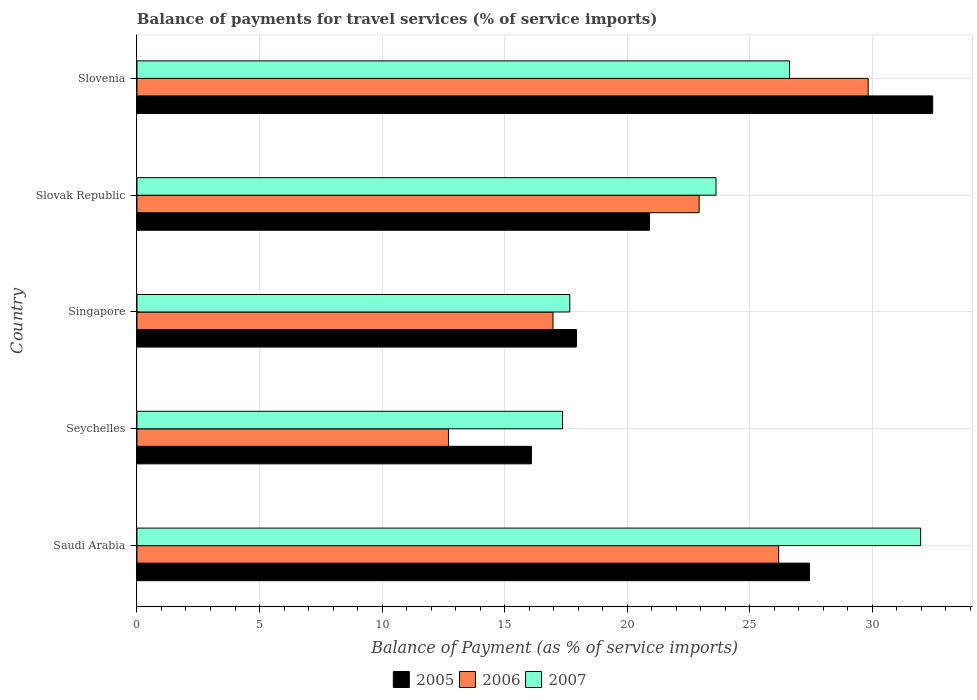How many groups of bars are there?
Your response must be concise. 5. How many bars are there on the 1st tick from the top?
Your answer should be very brief. 3. What is the label of the 1st group of bars from the top?
Offer a very short reply. Slovenia. What is the balance of payments for travel services in 2007 in Slovak Republic?
Ensure brevity in your answer.  23.62. Across all countries, what is the maximum balance of payments for travel services in 2007?
Provide a succinct answer. 31.97. Across all countries, what is the minimum balance of payments for travel services in 2007?
Ensure brevity in your answer.  17.36. In which country was the balance of payments for travel services in 2007 maximum?
Make the answer very short. Saudi Arabia. In which country was the balance of payments for travel services in 2006 minimum?
Your answer should be compact. Seychelles. What is the total balance of payments for travel services in 2006 in the graph?
Give a very brief answer. 108.62. What is the difference between the balance of payments for travel services in 2007 in Seychelles and that in Slovenia?
Give a very brief answer. -9.26. What is the difference between the balance of payments for travel services in 2007 in Slovak Republic and the balance of payments for travel services in 2006 in Singapore?
Your answer should be compact. 6.65. What is the average balance of payments for travel services in 2005 per country?
Provide a succinct answer. 22.97. What is the difference between the balance of payments for travel services in 2007 and balance of payments for travel services in 2006 in Seychelles?
Offer a very short reply. 4.65. In how many countries, is the balance of payments for travel services in 2006 greater than 17 %?
Your answer should be very brief. 3. What is the ratio of the balance of payments for travel services in 2006 in Seychelles to that in Singapore?
Your answer should be very brief. 0.75. What is the difference between the highest and the second highest balance of payments for travel services in 2007?
Give a very brief answer. 5.35. What is the difference between the highest and the lowest balance of payments for travel services in 2006?
Provide a short and direct response. 17.12. Is the sum of the balance of payments for travel services in 2005 in Saudi Arabia and Seychelles greater than the maximum balance of payments for travel services in 2006 across all countries?
Make the answer very short. Yes. What does the 1st bar from the bottom in Slovenia represents?
Provide a short and direct response. 2005. How many bars are there?
Keep it short and to the point. 15. Are all the bars in the graph horizontal?
Provide a succinct answer. Yes. What is the difference between two consecutive major ticks on the X-axis?
Provide a short and direct response. 5. Does the graph contain any zero values?
Provide a succinct answer. No. Does the graph contain grids?
Give a very brief answer. Yes. Where does the legend appear in the graph?
Your answer should be compact. Bottom center. How are the legend labels stacked?
Offer a terse response. Horizontal. What is the title of the graph?
Provide a short and direct response. Balance of payments for travel services (% of service imports). Does "1970" appear as one of the legend labels in the graph?
Keep it short and to the point. No. What is the label or title of the X-axis?
Your answer should be compact. Balance of Payment (as % of service imports). What is the Balance of Payment (as % of service imports) of 2005 in Saudi Arabia?
Your answer should be compact. 27.44. What is the Balance of Payment (as % of service imports) in 2006 in Saudi Arabia?
Ensure brevity in your answer.  26.18. What is the Balance of Payment (as % of service imports) of 2007 in Saudi Arabia?
Offer a very short reply. 31.97. What is the Balance of Payment (as % of service imports) in 2005 in Seychelles?
Ensure brevity in your answer.  16.09. What is the Balance of Payment (as % of service imports) in 2006 in Seychelles?
Offer a terse response. 12.71. What is the Balance of Payment (as % of service imports) of 2007 in Seychelles?
Ensure brevity in your answer.  17.36. What is the Balance of Payment (as % of service imports) in 2005 in Singapore?
Your response must be concise. 17.93. What is the Balance of Payment (as % of service imports) in 2006 in Singapore?
Your response must be concise. 16.97. What is the Balance of Payment (as % of service imports) in 2007 in Singapore?
Your answer should be compact. 17.66. What is the Balance of Payment (as % of service imports) in 2005 in Slovak Republic?
Offer a terse response. 20.91. What is the Balance of Payment (as % of service imports) of 2006 in Slovak Republic?
Your response must be concise. 22.93. What is the Balance of Payment (as % of service imports) of 2007 in Slovak Republic?
Give a very brief answer. 23.62. What is the Balance of Payment (as % of service imports) in 2005 in Slovenia?
Ensure brevity in your answer.  32.46. What is the Balance of Payment (as % of service imports) in 2006 in Slovenia?
Your response must be concise. 29.83. What is the Balance of Payment (as % of service imports) in 2007 in Slovenia?
Give a very brief answer. 26.62. Across all countries, what is the maximum Balance of Payment (as % of service imports) in 2005?
Give a very brief answer. 32.46. Across all countries, what is the maximum Balance of Payment (as % of service imports) of 2006?
Offer a terse response. 29.83. Across all countries, what is the maximum Balance of Payment (as % of service imports) in 2007?
Your response must be concise. 31.97. Across all countries, what is the minimum Balance of Payment (as % of service imports) of 2005?
Keep it short and to the point. 16.09. Across all countries, what is the minimum Balance of Payment (as % of service imports) of 2006?
Offer a terse response. 12.71. Across all countries, what is the minimum Balance of Payment (as % of service imports) in 2007?
Your answer should be very brief. 17.36. What is the total Balance of Payment (as % of service imports) in 2005 in the graph?
Offer a terse response. 114.83. What is the total Balance of Payment (as % of service imports) of 2006 in the graph?
Give a very brief answer. 108.62. What is the total Balance of Payment (as % of service imports) of 2007 in the graph?
Your response must be concise. 117.23. What is the difference between the Balance of Payment (as % of service imports) in 2005 in Saudi Arabia and that in Seychelles?
Provide a short and direct response. 11.34. What is the difference between the Balance of Payment (as % of service imports) of 2006 in Saudi Arabia and that in Seychelles?
Your answer should be compact. 13.47. What is the difference between the Balance of Payment (as % of service imports) in 2007 in Saudi Arabia and that in Seychelles?
Ensure brevity in your answer.  14.61. What is the difference between the Balance of Payment (as % of service imports) of 2005 in Saudi Arabia and that in Singapore?
Provide a succinct answer. 9.51. What is the difference between the Balance of Payment (as % of service imports) in 2006 in Saudi Arabia and that in Singapore?
Your response must be concise. 9.2. What is the difference between the Balance of Payment (as % of service imports) in 2007 in Saudi Arabia and that in Singapore?
Offer a very short reply. 14.31. What is the difference between the Balance of Payment (as % of service imports) of 2005 in Saudi Arabia and that in Slovak Republic?
Offer a terse response. 6.53. What is the difference between the Balance of Payment (as % of service imports) in 2006 in Saudi Arabia and that in Slovak Republic?
Your answer should be compact. 3.24. What is the difference between the Balance of Payment (as % of service imports) in 2007 in Saudi Arabia and that in Slovak Republic?
Ensure brevity in your answer.  8.35. What is the difference between the Balance of Payment (as % of service imports) in 2005 in Saudi Arabia and that in Slovenia?
Offer a very short reply. -5.03. What is the difference between the Balance of Payment (as % of service imports) in 2006 in Saudi Arabia and that in Slovenia?
Offer a very short reply. -3.65. What is the difference between the Balance of Payment (as % of service imports) of 2007 in Saudi Arabia and that in Slovenia?
Give a very brief answer. 5.35. What is the difference between the Balance of Payment (as % of service imports) in 2005 in Seychelles and that in Singapore?
Ensure brevity in your answer.  -1.84. What is the difference between the Balance of Payment (as % of service imports) in 2006 in Seychelles and that in Singapore?
Provide a short and direct response. -4.26. What is the difference between the Balance of Payment (as % of service imports) of 2007 in Seychelles and that in Singapore?
Your answer should be compact. -0.29. What is the difference between the Balance of Payment (as % of service imports) in 2005 in Seychelles and that in Slovak Republic?
Ensure brevity in your answer.  -4.82. What is the difference between the Balance of Payment (as % of service imports) in 2006 in Seychelles and that in Slovak Republic?
Ensure brevity in your answer.  -10.23. What is the difference between the Balance of Payment (as % of service imports) in 2007 in Seychelles and that in Slovak Republic?
Keep it short and to the point. -6.26. What is the difference between the Balance of Payment (as % of service imports) in 2005 in Seychelles and that in Slovenia?
Keep it short and to the point. -16.37. What is the difference between the Balance of Payment (as % of service imports) of 2006 in Seychelles and that in Slovenia?
Give a very brief answer. -17.12. What is the difference between the Balance of Payment (as % of service imports) in 2007 in Seychelles and that in Slovenia?
Provide a short and direct response. -9.26. What is the difference between the Balance of Payment (as % of service imports) in 2005 in Singapore and that in Slovak Republic?
Make the answer very short. -2.98. What is the difference between the Balance of Payment (as % of service imports) of 2006 in Singapore and that in Slovak Republic?
Your answer should be very brief. -5.96. What is the difference between the Balance of Payment (as % of service imports) of 2007 in Singapore and that in Slovak Republic?
Ensure brevity in your answer.  -5.97. What is the difference between the Balance of Payment (as % of service imports) of 2005 in Singapore and that in Slovenia?
Keep it short and to the point. -14.53. What is the difference between the Balance of Payment (as % of service imports) of 2006 in Singapore and that in Slovenia?
Your response must be concise. -12.86. What is the difference between the Balance of Payment (as % of service imports) of 2007 in Singapore and that in Slovenia?
Your answer should be very brief. -8.96. What is the difference between the Balance of Payment (as % of service imports) of 2005 in Slovak Republic and that in Slovenia?
Provide a short and direct response. -11.55. What is the difference between the Balance of Payment (as % of service imports) of 2006 in Slovak Republic and that in Slovenia?
Keep it short and to the point. -6.9. What is the difference between the Balance of Payment (as % of service imports) of 2007 in Slovak Republic and that in Slovenia?
Your response must be concise. -3. What is the difference between the Balance of Payment (as % of service imports) of 2005 in Saudi Arabia and the Balance of Payment (as % of service imports) of 2006 in Seychelles?
Your answer should be compact. 14.73. What is the difference between the Balance of Payment (as % of service imports) in 2005 in Saudi Arabia and the Balance of Payment (as % of service imports) in 2007 in Seychelles?
Give a very brief answer. 10.07. What is the difference between the Balance of Payment (as % of service imports) in 2006 in Saudi Arabia and the Balance of Payment (as % of service imports) in 2007 in Seychelles?
Give a very brief answer. 8.82. What is the difference between the Balance of Payment (as % of service imports) of 2005 in Saudi Arabia and the Balance of Payment (as % of service imports) of 2006 in Singapore?
Offer a terse response. 10.46. What is the difference between the Balance of Payment (as % of service imports) in 2005 in Saudi Arabia and the Balance of Payment (as % of service imports) in 2007 in Singapore?
Keep it short and to the point. 9.78. What is the difference between the Balance of Payment (as % of service imports) of 2006 in Saudi Arabia and the Balance of Payment (as % of service imports) of 2007 in Singapore?
Your response must be concise. 8.52. What is the difference between the Balance of Payment (as % of service imports) in 2005 in Saudi Arabia and the Balance of Payment (as % of service imports) in 2006 in Slovak Republic?
Your response must be concise. 4.5. What is the difference between the Balance of Payment (as % of service imports) in 2005 in Saudi Arabia and the Balance of Payment (as % of service imports) in 2007 in Slovak Republic?
Your answer should be very brief. 3.81. What is the difference between the Balance of Payment (as % of service imports) in 2006 in Saudi Arabia and the Balance of Payment (as % of service imports) in 2007 in Slovak Republic?
Provide a short and direct response. 2.56. What is the difference between the Balance of Payment (as % of service imports) of 2005 in Saudi Arabia and the Balance of Payment (as % of service imports) of 2006 in Slovenia?
Provide a succinct answer. -2.39. What is the difference between the Balance of Payment (as % of service imports) in 2005 in Saudi Arabia and the Balance of Payment (as % of service imports) in 2007 in Slovenia?
Provide a short and direct response. 0.82. What is the difference between the Balance of Payment (as % of service imports) in 2006 in Saudi Arabia and the Balance of Payment (as % of service imports) in 2007 in Slovenia?
Provide a short and direct response. -0.44. What is the difference between the Balance of Payment (as % of service imports) of 2005 in Seychelles and the Balance of Payment (as % of service imports) of 2006 in Singapore?
Give a very brief answer. -0.88. What is the difference between the Balance of Payment (as % of service imports) in 2005 in Seychelles and the Balance of Payment (as % of service imports) in 2007 in Singapore?
Provide a short and direct response. -1.56. What is the difference between the Balance of Payment (as % of service imports) in 2006 in Seychelles and the Balance of Payment (as % of service imports) in 2007 in Singapore?
Provide a short and direct response. -4.95. What is the difference between the Balance of Payment (as % of service imports) of 2005 in Seychelles and the Balance of Payment (as % of service imports) of 2006 in Slovak Republic?
Your answer should be compact. -6.84. What is the difference between the Balance of Payment (as % of service imports) of 2005 in Seychelles and the Balance of Payment (as % of service imports) of 2007 in Slovak Republic?
Offer a very short reply. -7.53. What is the difference between the Balance of Payment (as % of service imports) in 2006 in Seychelles and the Balance of Payment (as % of service imports) in 2007 in Slovak Republic?
Make the answer very short. -10.91. What is the difference between the Balance of Payment (as % of service imports) of 2005 in Seychelles and the Balance of Payment (as % of service imports) of 2006 in Slovenia?
Your answer should be compact. -13.74. What is the difference between the Balance of Payment (as % of service imports) of 2005 in Seychelles and the Balance of Payment (as % of service imports) of 2007 in Slovenia?
Your answer should be compact. -10.53. What is the difference between the Balance of Payment (as % of service imports) of 2006 in Seychelles and the Balance of Payment (as % of service imports) of 2007 in Slovenia?
Make the answer very short. -13.91. What is the difference between the Balance of Payment (as % of service imports) of 2005 in Singapore and the Balance of Payment (as % of service imports) of 2006 in Slovak Republic?
Your answer should be very brief. -5. What is the difference between the Balance of Payment (as % of service imports) in 2005 in Singapore and the Balance of Payment (as % of service imports) in 2007 in Slovak Republic?
Give a very brief answer. -5.69. What is the difference between the Balance of Payment (as % of service imports) in 2006 in Singapore and the Balance of Payment (as % of service imports) in 2007 in Slovak Republic?
Provide a short and direct response. -6.65. What is the difference between the Balance of Payment (as % of service imports) of 2005 in Singapore and the Balance of Payment (as % of service imports) of 2006 in Slovenia?
Your answer should be compact. -11.9. What is the difference between the Balance of Payment (as % of service imports) of 2005 in Singapore and the Balance of Payment (as % of service imports) of 2007 in Slovenia?
Make the answer very short. -8.69. What is the difference between the Balance of Payment (as % of service imports) of 2006 in Singapore and the Balance of Payment (as % of service imports) of 2007 in Slovenia?
Keep it short and to the point. -9.65. What is the difference between the Balance of Payment (as % of service imports) in 2005 in Slovak Republic and the Balance of Payment (as % of service imports) in 2006 in Slovenia?
Offer a very short reply. -8.92. What is the difference between the Balance of Payment (as % of service imports) in 2005 in Slovak Republic and the Balance of Payment (as % of service imports) in 2007 in Slovenia?
Provide a succinct answer. -5.71. What is the difference between the Balance of Payment (as % of service imports) in 2006 in Slovak Republic and the Balance of Payment (as % of service imports) in 2007 in Slovenia?
Make the answer very short. -3.69. What is the average Balance of Payment (as % of service imports) of 2005 per country?
Provide a short and direct response. 22.97. What is the average Balance of Payment (as % of service imports) of 2006 per country?
Provide a succinct answer. 21.72. What is the average Balance of Payment (as % of service imports) of 2007 per country?
Your answer should be compact. 23.45. What is the difference between the Balance of Payment (as % of service imports) of 2005 and Balance of Payment (as % of service imports) of 2006 in Saudi Arabia?
Make the answer very short. 1.26. What is the difference between the Balance of Payment (as % of service imports) of 2005 and Balance of Payment (as % of service imports) of 2007 in Saudi Arabia?
Your answer should be compact. -4.53. What is the difference between the Balance of Payment (as % of service imports) in 2006 and Balance of Payment (as % of service imports) in 2007 in Saudi Arabia?
Offer a terse response. -5.79. What is the difference between the Balance of Payment (as % of service imports) in 2005 and Balance of Payment (as % of service imports) in 2006 in Seychelles?
Provide a succinct answer. 3.38. What is the difference between the Balance of Payment (as % of service imports) in 2005 and Balance of Payment (as % of service imports) in 2007 in Seychelles?
Make the answer very short. -1.27. What is the difference between the Balance of Payment (as % of service imports) of 2006 and Balance of Payment (as % of service imports) of 2007 in Seychelles?
Your answer should be compact. -4.65. What is the difference between the Balance of Payment (as % of service imports) in 2005 and Balance of Payment (as % of service imports) in 2006 in Singapore?
Keep it short and to the point. 0.96. What is the difference between the Balance of Payment (as % of service imports) of 2005 and Balance of Payment (as % of service imports) of 2007 in Singapore?
Give a very brief answer. 0.27. What is the difference between the Balance of Payment (as % of service imports) of 2006 and Balance of Payment (as % of service imports) of 2007 in Singapore?
Make the answer very short. -0.68. What is the difference between the Balance of Payment (as % of service imports) in 2005 and Balance of Payment (as % of service imports) in 2006 in Slovak Republic?
Offer a very short reply. -2.02. What is the difference between the Balance of Payment (as % of service imports) of 2005 and Balance of Payment (as % of service imports) of 2007 in Slovak Republic?
Your answer should be very brief. -2.71. What is the difference between the Balance of Payment (as % of service imports) in 2006 and Balance of Payment (as % of service imports) in 2007 in Slovak Republic?
Make the answer very short. -0.69. What is the difference between the Balance of Payment (as % of service imports) in 2005 and Balance of Payment (as % of service imports) in 2006 in Slovenia?
Provide a succinct answer. 2.63. What is the difference between the Balance of Payment (as % of service imports) of 2005 and Balance of Payment (as % of service imports) of 2007 in Slovenia?
Your response must be concise. 5.84. What is the difference between the Balance of Payment (as % of service imports) of 2006 and Balance of Payment (as % of service imports) of 2007 in Slovenia?
Make the answer very short. 3.21. What is the ratio of the Balance of Payment (as % of service imports) of 2005 in Saudi Arabia to that in Seychelles?
Your response must be concise. 1.71. What is the ratio of the Balance of Payment (as % of service imports) in 2006 in Saudi Arabia to that in Seychelles?
Keep it short and to the point. 2.06. What is the ratio of the Balance of Payment (as % of service imports) of 2007 in Saudi Arabia to that in Seychelles?
Offer a terse response. 1.84. What is the ratio of the Balance of Payment (as % of service imports) of 2005 in Saudi Arabia to that in Singapore?
Ensure brevity in your answer.  1.53. What is the ratio of the Balance of Payment (as % of service imports) in 2006 in Saudi Arabia to that in Singapore?
Keep it short and to the point. 1.54. What is the ratio of the Balance of Payment (as % of service imports) of 2007 in Saudi Arabia to that in Singapore?
Give a very brief answer. 1.81. What is the ratio of the Balance of Payment (as % of service imports) of 2005 in Saudi Arabia to that in Slovak Republic?
Provide a short and direct response. 1.31. What is the ratio of the Balance of Payment (as % of service imports) of 2006 in Saudi Arabia to that in Slovak Republic?
Provide a short and direct response. 1.14. What is the ratio of the Balance of Payment (as % of service imports) of 2007 in Saudi Arabia to that in Slovak Republic?
Offer a terse response. 1.35. What is the ratio of the Balance of Payment (as % of service imports) in 2005 in Saudi Arabia to that in Slovenia?
Offer a very short reply. 0.85. What is the ratio of the Balance of Payment (as % of service imports) of 2006 in Saudi Arabia to that in Slovenia?
Keep it short and to the point. 0.88. What is the ratio of the Balance of Payment (as % of service imports) in 2007 in Saudi Arabia to that in Slovenia?
Provide a short and direct response. 1.2. What is the ratio of the Balance of Payment (as % of service imports) of 2005 in Seychelles to that in Singapore?
Provide a short and direct response. 0.9. What is the ratio of the Balance of Payment (as % of service imports) in 2006 in Seychelles to that in Singapore?
Provide a short and direct response. 0.75. What is the ratio of the Balance of Payment (as % of service imports) in 2007 in Seychelles to that in Singapore?
Your answer should be compact. 0.98. What is the ratio of the Balance of Payment (as % of service imports) of 2005 in Seychelles to that in Slovak Republic?
Your response must be concise. 0.77. What is the ratio of the Balance of Payment (as % of service imports) of 2006 in Seychelles to that in Slovak Republic?
Provide a succinct answer. 0.55. What is the ratio of the Balance of Payment (as % of service imports) of 2007 in Seychelles to that in Slovak Republic?
Provide a succinct answer. 0.73. What is the ratio of the Balance of Payment (as % of service imports) in 2005 in Seychelles to that in Slovenia?
Your response must be concise. 0.5. What is the ratio of the Balance of Payment (as % of service imports) in 2006 in Seychelles to that in Slovenia?
Keep it short and to the point. 0.43. What is the ratio of the Balance of Payment (as % of service imports) of 2007 in Seychelles to that in Slovenia?
Your response must be concise. 0.65. What is the ratio of the Balance of Payment (as % of service imports) in 2005 in Singapore to that in Slovak Republic?
Keep it short and to the point. 0.86. What is the ratio of the Balance of Payment (as % of service imports) of 2006 in Singapore to that in Slovak Republic?
Provide a succinct answer. 0.74. What is the ratio of the Balance of Payment (as % of service imports) of 2007 in Singapore to that in Slovak Republic?
Provide a short and direct response. 0.75. What is the ratio of the Balance of Payment (as % of service imports) of 2005 in Singapore to that in Slovenia?
Provide a succinct answer. 0.55. What is the ratio of the Balance of Payment (as % of service imports) in 2006 in Singapore to that in Slovenia?
Give a very brief answer. 0.57. What is the ratio of the Balance of Payment (as % of service imports) in 2007 in Singapore to that in Slovenia?
Your answer should be very brief. 0.66. What is the ratio of the Balance of Payment (as % of service imports) in 2005 in Slovak Republic to that in Slovenia?
Your answer should be very brief. 0.64. What is the ratio of the Balance of Payment (as % of service imports) of 2006 in Slovak Republic to that in Slovenia?
Ensure brevity in your answer.  0.77. What is the ratio of the Balance of Payment (as % of service imports) of 2007 in Slovak Republic to that in Slovenia?
Make the answer very short. 0.89. What is the difference between the highest and the second highest Balance of Payment (as % of service imports) of 2005?
Give a very brief answer. 5.03. What is the difference between the highest and the second highest Balance of Payment (as % of service imports) in 2006?
Ensure brevity in your answer.  3.65. What is the difference between the highest and the second highest Balance of Payment (as % of service imports) in 2007?
Ensure brevity in your answer.  5.35. What is the difference between the highest and the lowest Balance of Payment (as % of service imports) in 2005?
Offer a terse response. 16.37. What is the difference between the highest and the lowest Balance of Payment (as % of service imports) of 2006?
Your response must be concise. 17.12. What is the difference between the highest and the lowest Balance of Payment (as % of service imports) of 2007?
Your answer should be very brief. 14.61. 